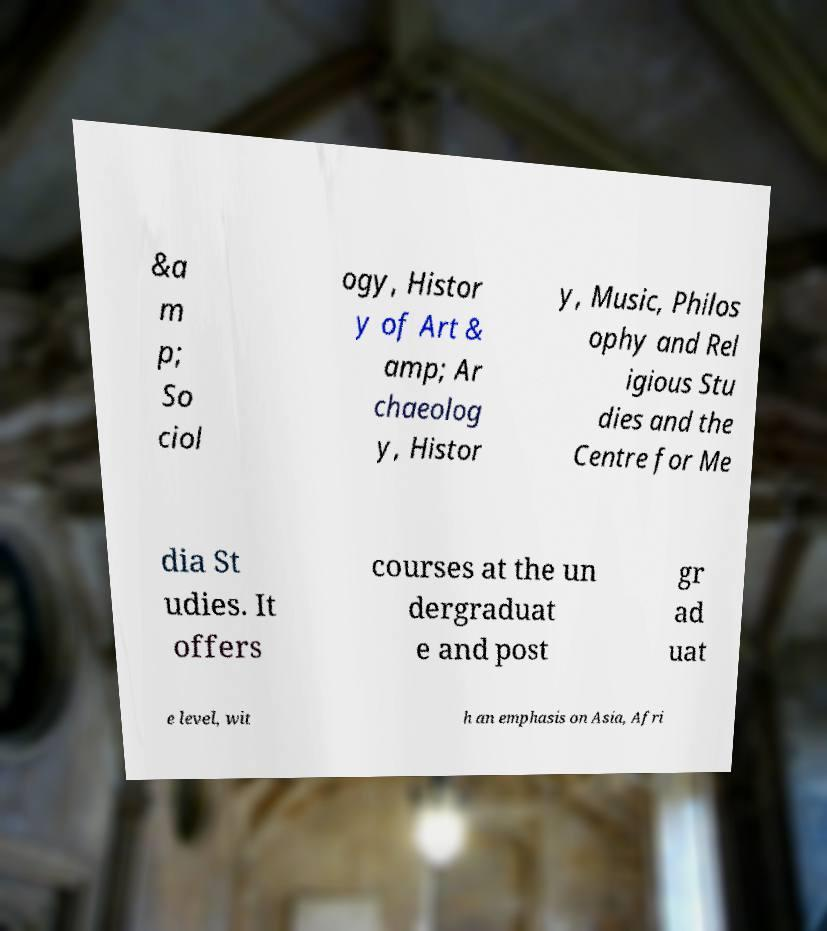Could you extract and type out the text from this image? &a m p; So ciol ogy, Histor y of Art & amp; Ar chaeolog y, Histor y, Music, Philos ophy and Rel igious Stu dies and the Centre for Me dia St udies. It offers courses at the un dergraduat e and post gr ad uat e level, wit h an emphasis on Asia, Afri 